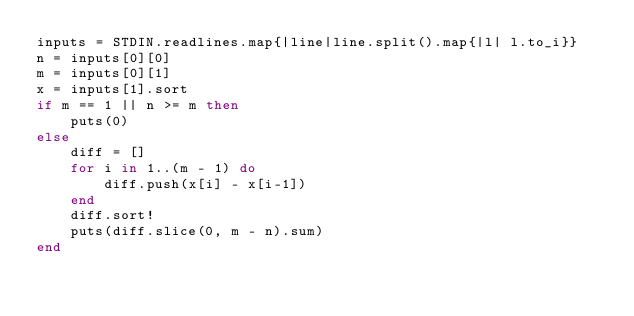<code> <loc_0><loc_0><loc_500><loc_500><_Ruby_>inputs = STDIN.readlines.map{|line|line.split().map{|l| l.to_i}}
n = inputs[0][0]
m = inputs[0][1]
x = inputs[1].sort
if m == 1 || n >= m then
    puts(0)
else
    diff = []
    for i in 1..(m - 1) do
        diff.push(x[i] - x[i-1])
    end
    diff.sort!
    puts(diff.slice(0, m - n).sum)
end</code> 